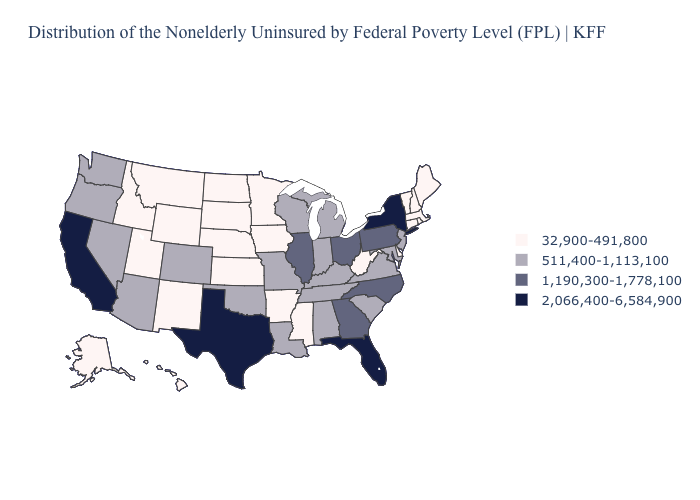What is the value of Vermont?
Quick response, please. 32,900-491,800. Name the states that have a value in the range 1,190,300-1,778,100?
Be succinct. Georgia, Illinois, North Carolina, Ohio, Pennsylvania. Does Nevada have the same value as Michigan?
Give a very brief answer. Yes. Which states have the lowest value in the South?
Write a very short answer. Arkansas, Delaware, Mississippi, West Virginia. Does the first symbol in the legend represent the smallest category?
Quick response, please. Yes. What is the highest value in the West ?
Quick response, please. 2,066,400-6,584,900. Which states have the lowest value in the USA?
Concise answer only. Alaska, Arkansas, Connecticut, Delaware, Hawaii, Idaho, Iowa, Kansas, Maine, Massachusetts, Minnesota, Mississippi, Montana, Nebraska, New Hampshire, New Mexico, North Dakota, Rhode Island, South Dakota, Utah, Vermont, West Virginia, Wyoming. Does Kansas have the highest value in the MidWest?
Concise answer only. No. Does Arizona have the lowest value in the USA?
Quick response, please. No. Among the states that border Nebraska , which have the lowest value?
Give a very brief answer. Iowa, Kansas, South Dakota, Wyoming. Name the states that have a value in the range 511,400-1,113,100?
Be succinct. Alabama, Arizona, Colorado, Indiana, Kentucky, Louisiana, Maryland, Michigan, Missouri, Nevada, New Jersey, Oklahoma, Oregon, South Carolina, Tennessee, Virginia, Washington, Wisconsin. What is the value of Oregon?
Answer briefly. 511,400-1,113,100. Does Arizona have the lowest value in the West?
Answer briefly. No. What is the highest value in the USA?
Short answer required. 2,066,400-6,584,900. 